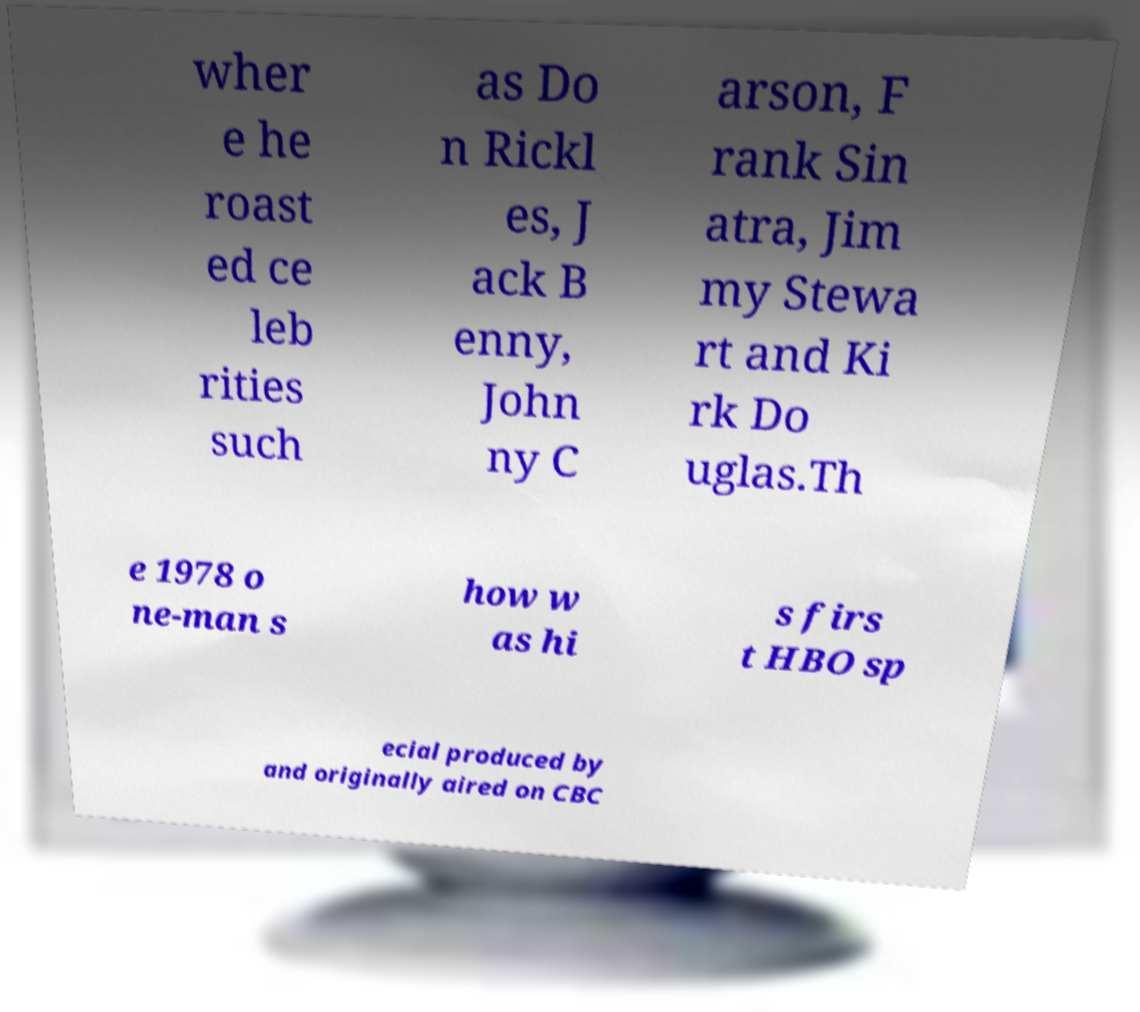Please identify and transcribe the text found in this image. wher e he roast ed ce leb rities such as Do n Rickl es, J ack B enny, John ny C arson, F rank Sin atra, Jim my Stewa rt and Ki rk Do uglas.Th e 1978 o ne-man s how w as hi s firs t HBO sp ecial produced by and originally aired on CBC 